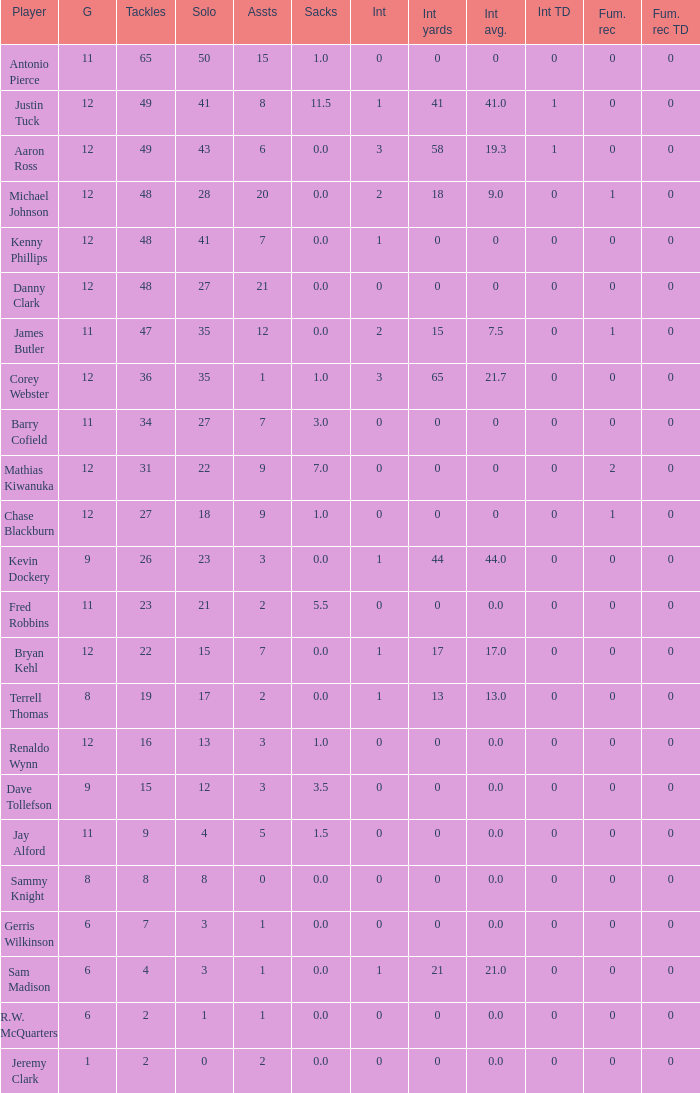Name the least int yards when sacks is 11.5 41.0. 